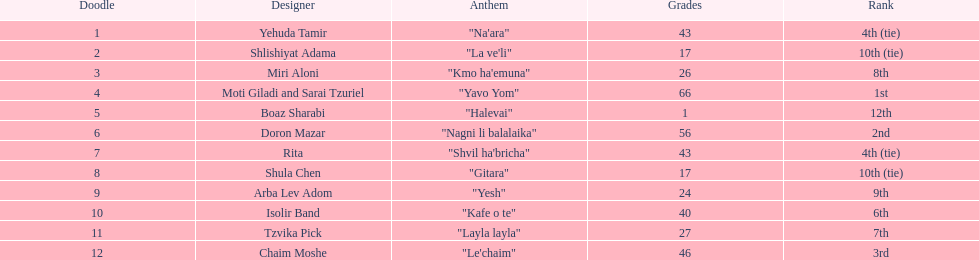Which artist had almost no points? Boaz Sharabi. 